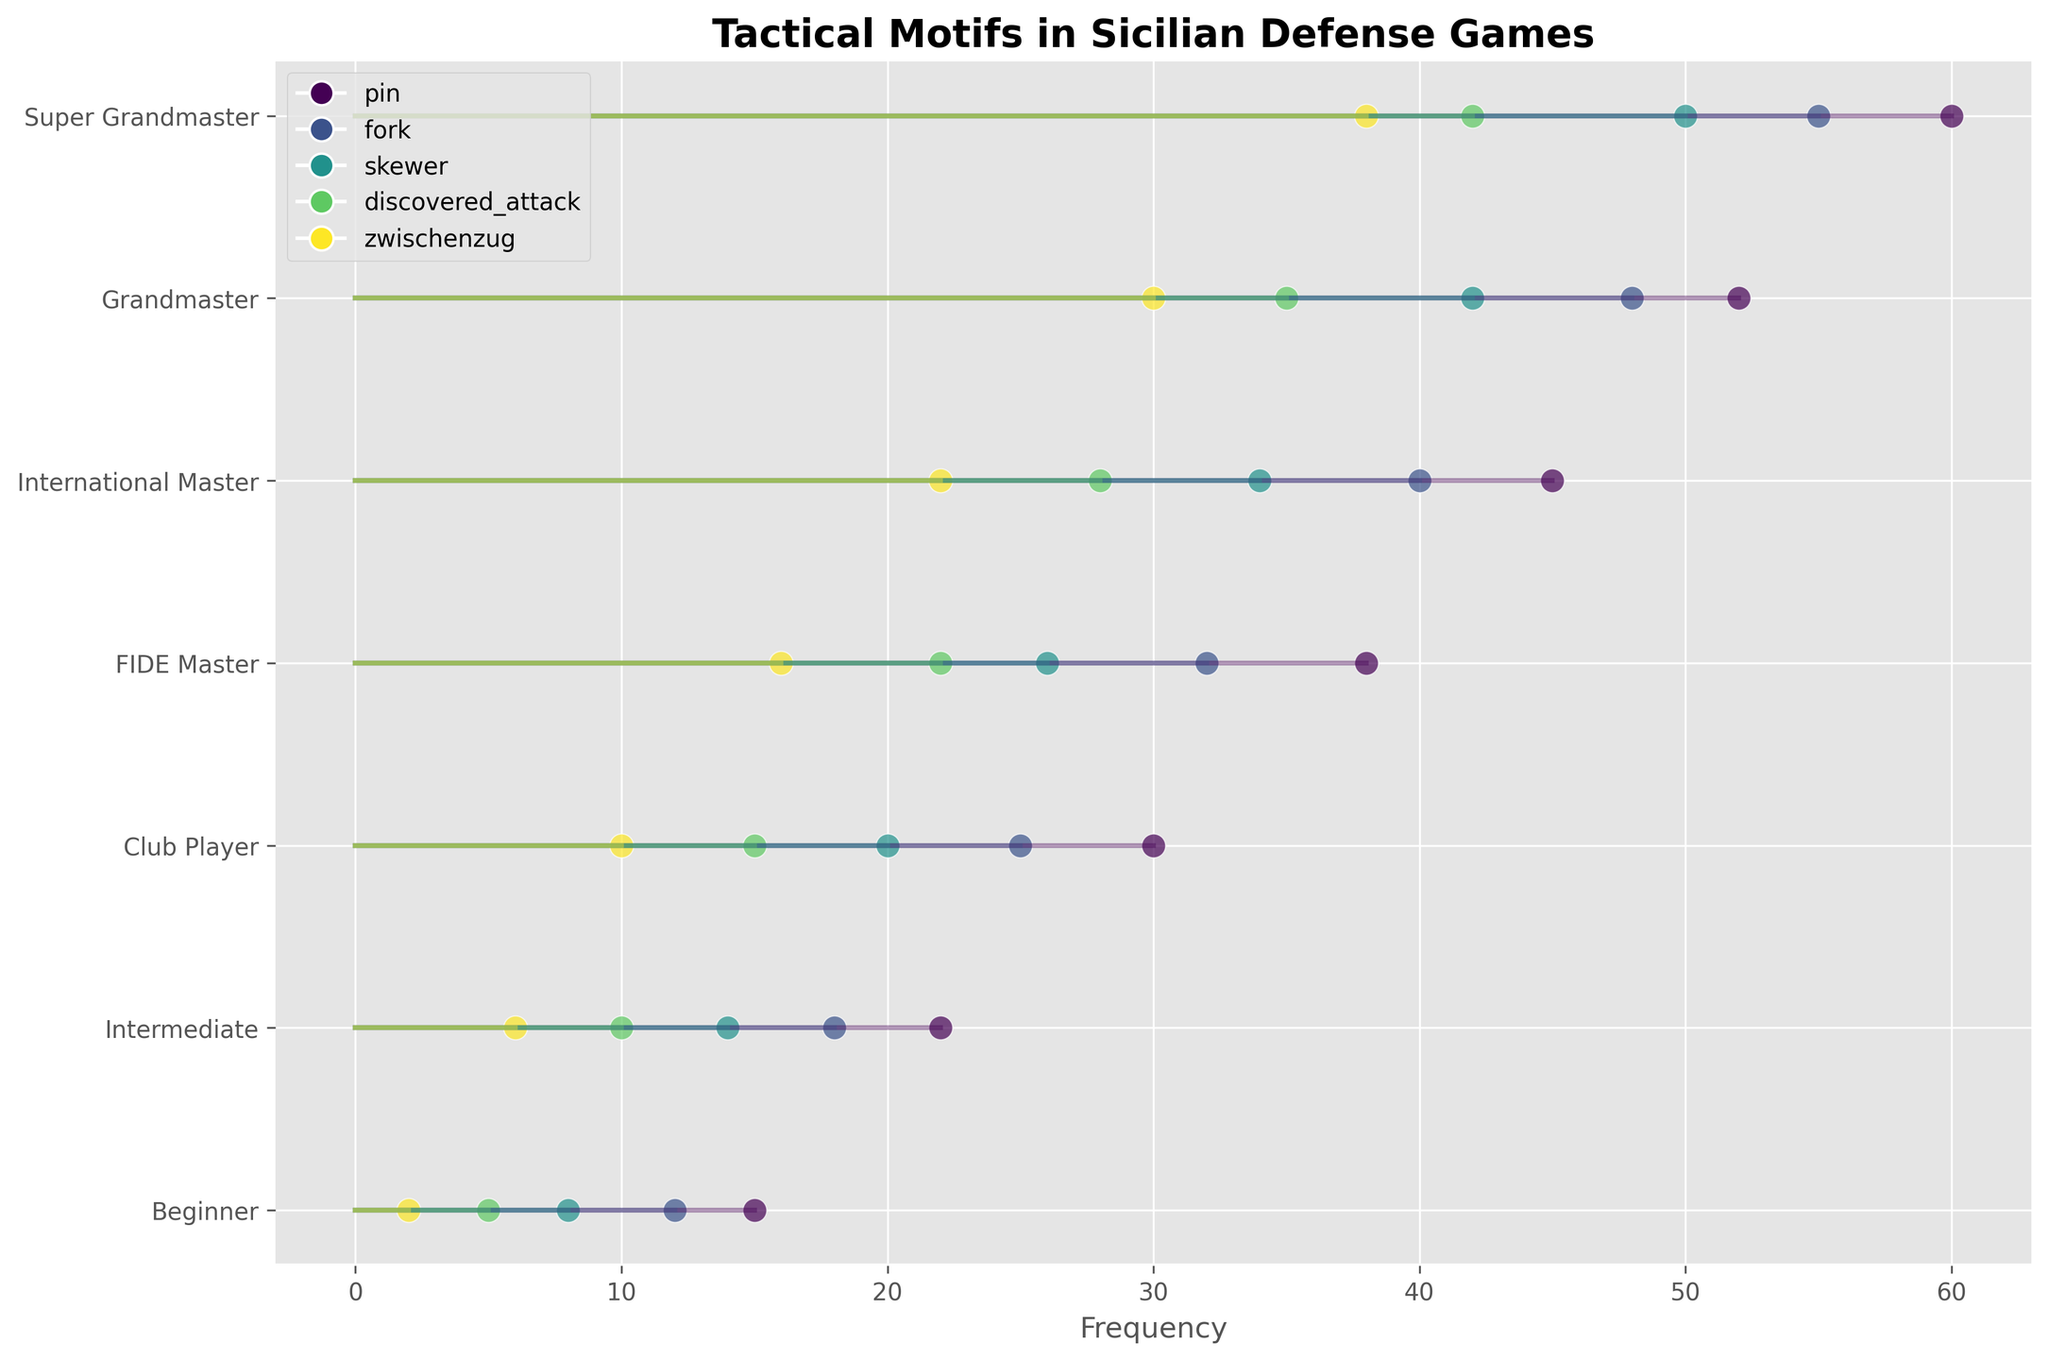What's the title of the figure? The title of the figure can be found at the top of the plot. It is typically displayed in larger, bold text to stand out.
Answer: Tactical Motifs in Sicilian Defense Games Which skill level shows the highest frequency of pins? Locate the category 'pins' in the plot, and then find the highest data point corresponding to each skill level. The skill level with the highest value indicates the highest frequency.
Answer: Super Grandmaster What is the frequency difference of forks between a Grandmaster and an Intermediate player? Identify the fork frequencies for both skill levels from the plot. Grandmaster has 48, and Intermediate has 18. Subtract the Intermediate value from the Grandmaster value (48 - 18).
Answer: 30 Which tactical motif tends to have the least frequency across different skill levels? Compare the different motif frequencies across all skill levels from the plot. Look for the motif that consistently has the smallest values.
Answer: Zwischenzug By looking at the plot, what is the combined frequency of skewer and pin for a Club Player? Identify and sum the skewer and pin frequencies for a Club Player from the plot. Pin is 30 and skewer is 20. Add them together (30 + 20).
Answer: 50 How does the frequency of discovered attacks change from a Beginner to a FIDE Master? Find the discovered attack frequencies for both skill levels. Beginner is 5, FIDE Master is 22. Observe the difference by subtracting the lower value from the higher value (22 - 5).
Answer: 17 Which two motifs have the closest frequencies for a Club Player, and what are they? Check the frequencies of all motifs for a Club Player. Identify the two motifs that have the smallest difference in their frequencies.
Answer: Pin (30) and fork (25) Do tactical motifs generally increase or decrease with skill level? Observe the trend lines of multiple motifs from Beginner to Super Grandmaster on the plot. Determine whether they tend to rise or fall as skill levels increase.
Answer: Increase Which motif has the highest increase in frequency from International Master to Super Grandmaster? Calculate the increase for each motif by subtracting the International Master values from the Super Grandmaster values. Identify the motif with the largest difference.
Answer: Pin (60 - 45 = 15) At what skill level does the frequency of discovered attacks first exceed 20? Look for the discovered attack values across different skill levels and identify the first instance where it exceeds 20.
Answer: FIDE Master 